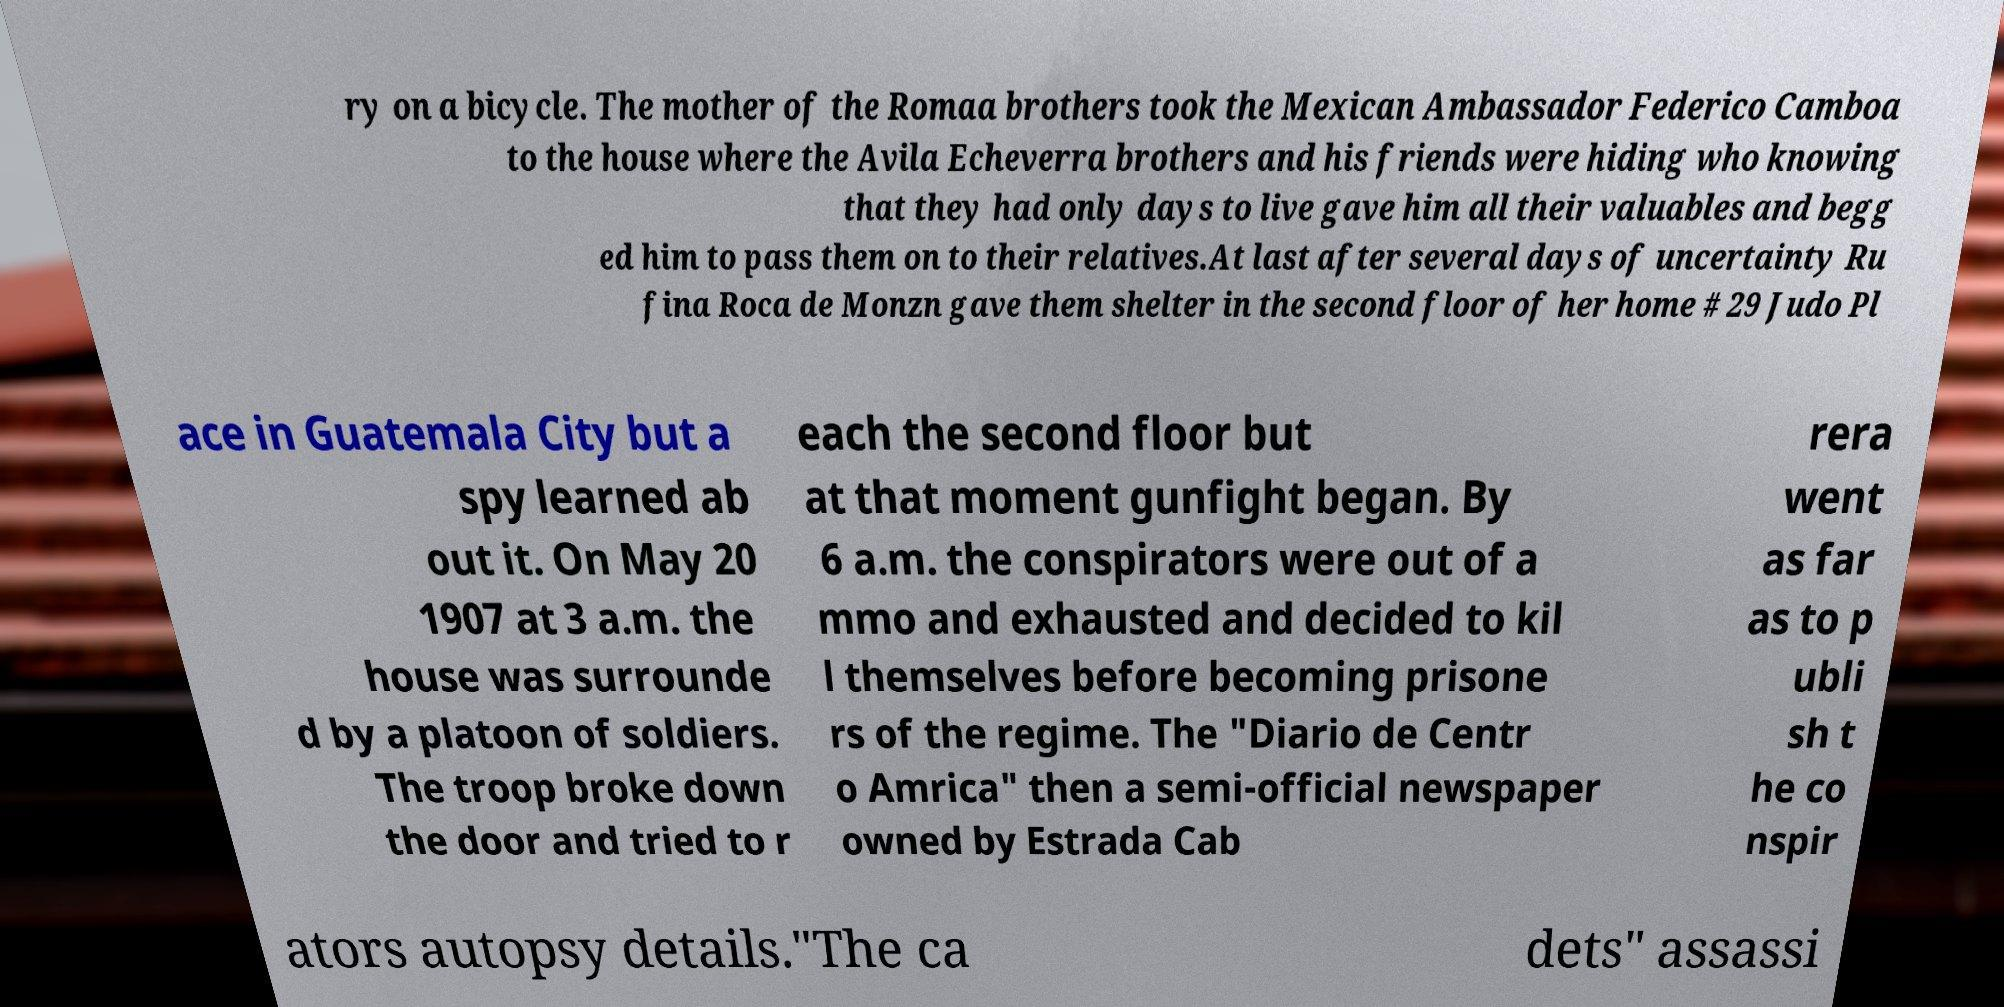What messages or text are displayed in this image? I need them in a readable, typed format. ry on a bicycle. The mother of the Romaa brothers took the Mexican Ambassador Federico Camboa to the house where the Avila Echeverra brothers and his friends were hiding who knowing that they had only days to live gave him all their valuables and begg ed him to pass them on to their relatives.At last after several days of uncertainty Ru fina Roca de Monzn gave them shelter in the second floor of her home # 29 Judo Pl ace in Guatemala City but a spy learned ab out it. On May 20 1907 at 3 a.m. the house was surrounde d by a platoon of soldiers. The troop broke down the door and tried to r each the second floor but at that moment gunfight began. By 6 a.m. the conspirators were out of a mmo and exhausted and decided to kil l themselves before becoming prisone rs of the regime. The "Diario de Centr o Amrica" then a semi-official newspaper owned by Estrada Cab rera went as far as to p ubli sh t he co nspir ators autopsy details."The ca dets" assassi 